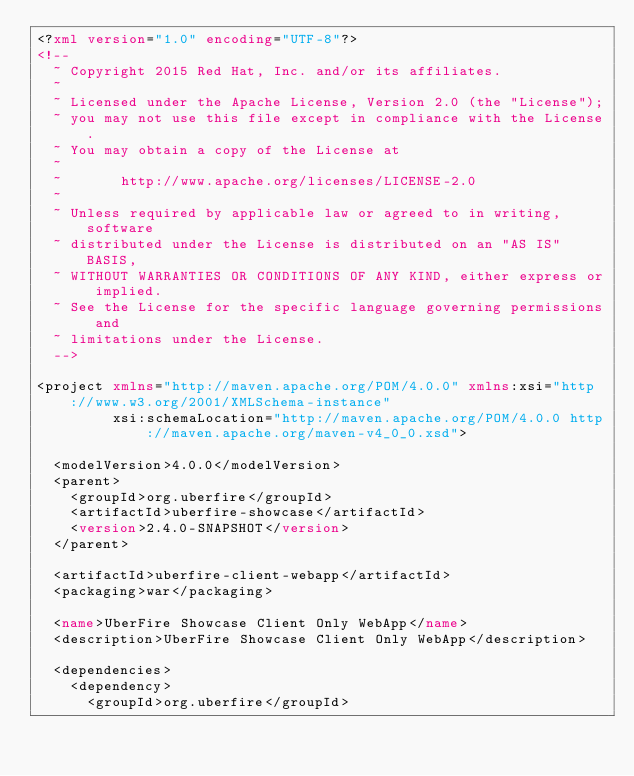Convert code to text. <code><loc_0><loc_0><loc_500><loc_500><_XML_><?xml version="1.0" encoding="UTF-8"?>
<!--
  ~ Copyright 2015 Red Hat, Inc. and/or its affiliates.
  ~
  ~ Licensed under the Apache License, Version 2.0 (the "License");
  ~ you may not use this file except in compliance with the License.
  ~ You may obtain a copy of the License at
  ~
  ~       http://www.apache.org/licenses/LICENSE-2.0
  ~
  ~ Unless required by applicable law or agreed to in writing, software
  ~ distributed under the License is distributed on an "AS IS" BASIS,
  ~ WITHOUT WARRANTIES OR CONDITIONS OF ANY KIND, either express or implied.
  ~ See the License for the specific language governing permissions and
  ~ limitations under the License.
  -->

<project xmlns="http://maven.apache.org/POM/4.0.0" xmlns:xsi="http://www.w3.org/2001/XMLSchema-instance"
         xsi:schemaLocation="http://maven.apache.org/POM/4.0.0 http://maven.apache.org/maven-v4_0_0.xsd">

  <modelVersion>4.0.0</modelVersion>
  <parent>
    <groupId>org.uberfire</groupId>
    <artifactId>uberfire-showcase</artifactId>
    <version>2.4.0-SNAPSHOT</version>
  </parent>

  <artifactId>uberfire-client-webapp</artifactId>
  <packaging>war</packaging>

  <name>UberFire Showcase Client Only WebApp</name>
  <description>UberFire Showcase Client Only WebApp</description>

  <dependencies>
    <dependency>
      <groupId>org.uberfire</groupId></code> 